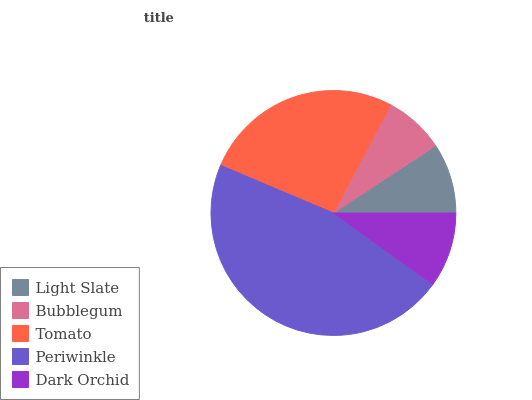Is Bubblegum the minimum?
Answer yes or no. Yes. Is Periwinkle the maximum?
Answer yes or no. Yes. Is Tomato the minimum?
Answer yes or no. No. Is Tomato the maximum?
Answer yes or no. No. Is Tomato greater than Bubblegum?
Answer yes or no. Yes. Is Bubblegum less than Tomato?
Answer yes or no. Yes. Is Bubblegum greater than Tomato?
Answer yes or no. No. Is Tomato less than Bubblegum?
Answer yes or no. No. Is Dark Orchid the high median?
Answer yes or no. Yes. Is Dark Orchid the low median?
Answer yes or no. Yes. Is Periwinkle the high median?
Answer yes or no. No. Is Light Slate the low median?
Answer yes or no. No. 